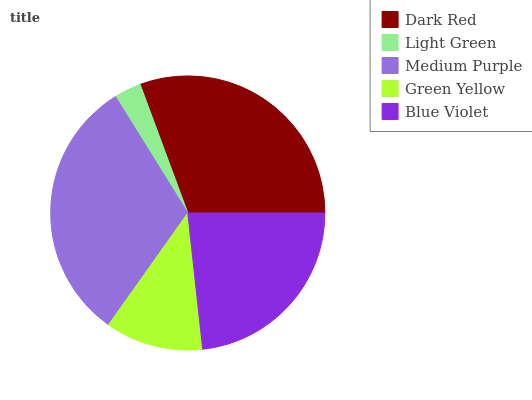Is Light Green the minimum?
Answer yes or no. Yes. Is Medium Purple the maximum?
Answer yes or no. Yes. Is Medium Purple the minimum?
Answer yes or no. No. Is Light Green the maximum?
Answer yes or no. No. Is Medium Purple greater than Light Green?
Answer yes or no. Yes. Is Light Green less than Medium Purple?
Answer yes or no. Yes. Is Light Green greater than Medium Purple?
Answer yes or no. No. Is Medium Purple less than Light Green?
Answer yes or no. No. Is Blue Violet the high median?
Answer yes or no. Yes. Is Blue Violet the low median?
Answer yes or no. Yes. Is Light Green the high median?
Answer yes or no. No. Is Dark Red the low median?
Answer yes or no. No. 